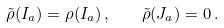Convert formula to latex. <formula><loc_0><loc_0><loc_500><loc_500>\tilde { \rho } ( I _ { a } ) = \rho ( I _ { a } ) \, , \quad \tilde { \rho } ( J _ { a } ) = 0 \, .</formula> 